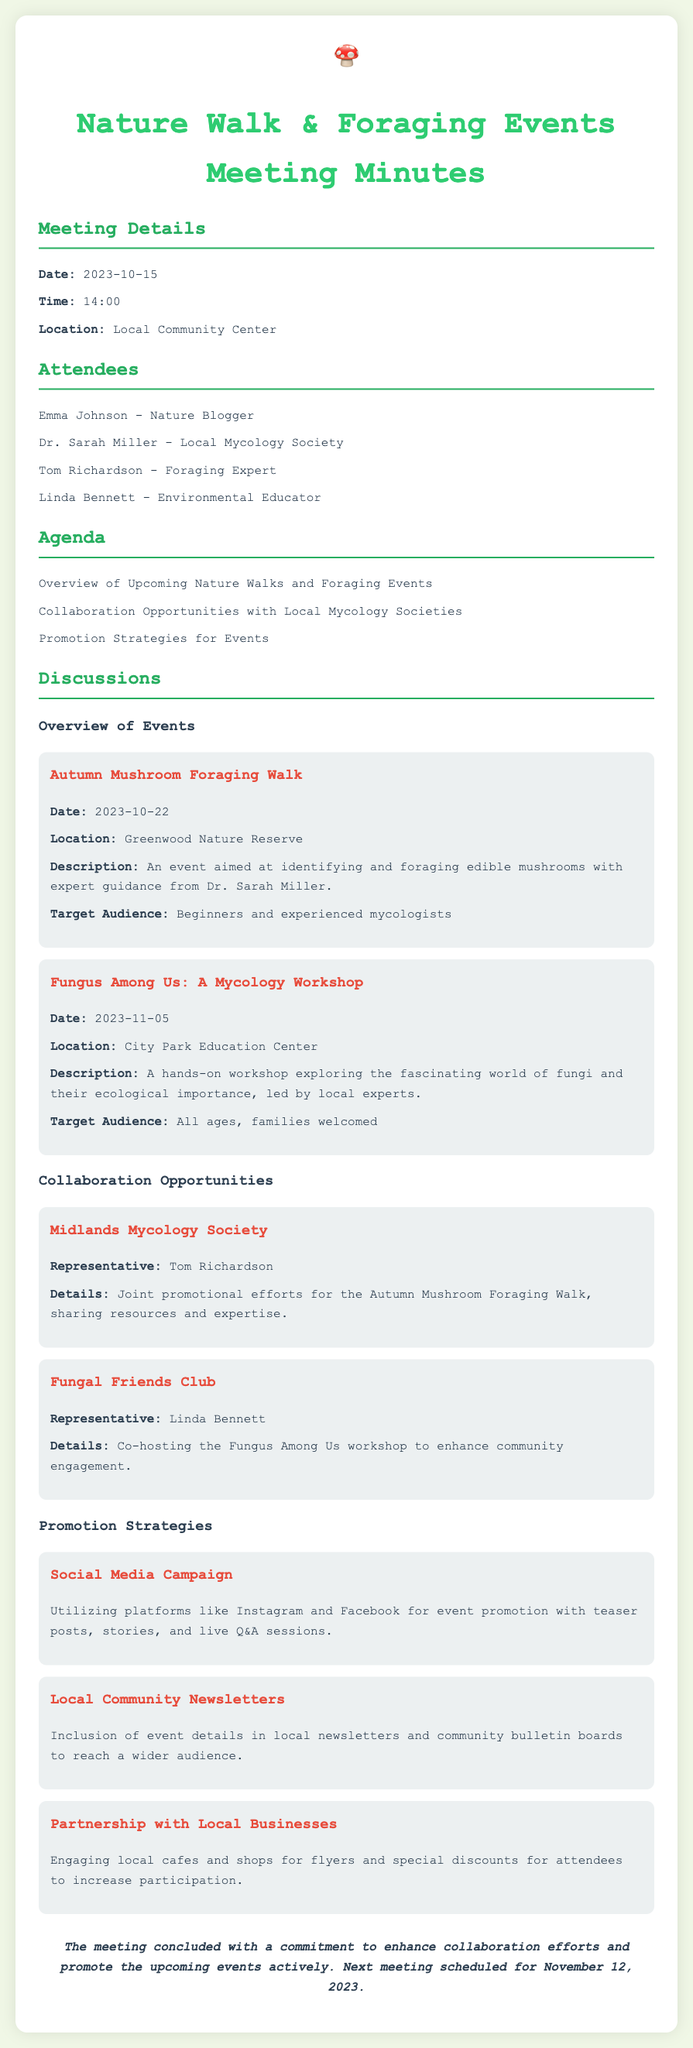What is the date of the next meeting? The next meeting is scheduled for a specific date mentioned in the conclusion section of the document.
Answer: November 12, 2023 Who is the representative for the Midlands Mycology Society? The representative is mentioned in the collaboration opportunities section of the document.
Answer: Tom Richardson What is the location of the Autumn Mushroom Foraging Walk? The location for this event is specified in the event details within the document.
Answer: Greenwood Nature Reserve What type of audience is targeted for the Fungus Among Us workshop? The target audience for this workshop is provided in the description of the event in the document.
Answer: All ages, families welcomed What social media platforms are mentioned for event promotion? The platforms mentioned for promotion are listed under the promotion strategies section of the document.
Answer: Instagram and Facebook How many events are listed in the Overview of Events section? The number of events is determined by counting the events detailed in the document.
Answer: Two What is the main focus of the Autumn Mushroom Foraging Walk? The main focus is articulated in the description of the event in the document.
Answer: Identifying and foraging edible mushrooms What collaboration opportunity involves co-hosting an event? This detail is found in the collaborations section, specifying joint efforts.
Answer: Fungal Friends Club 